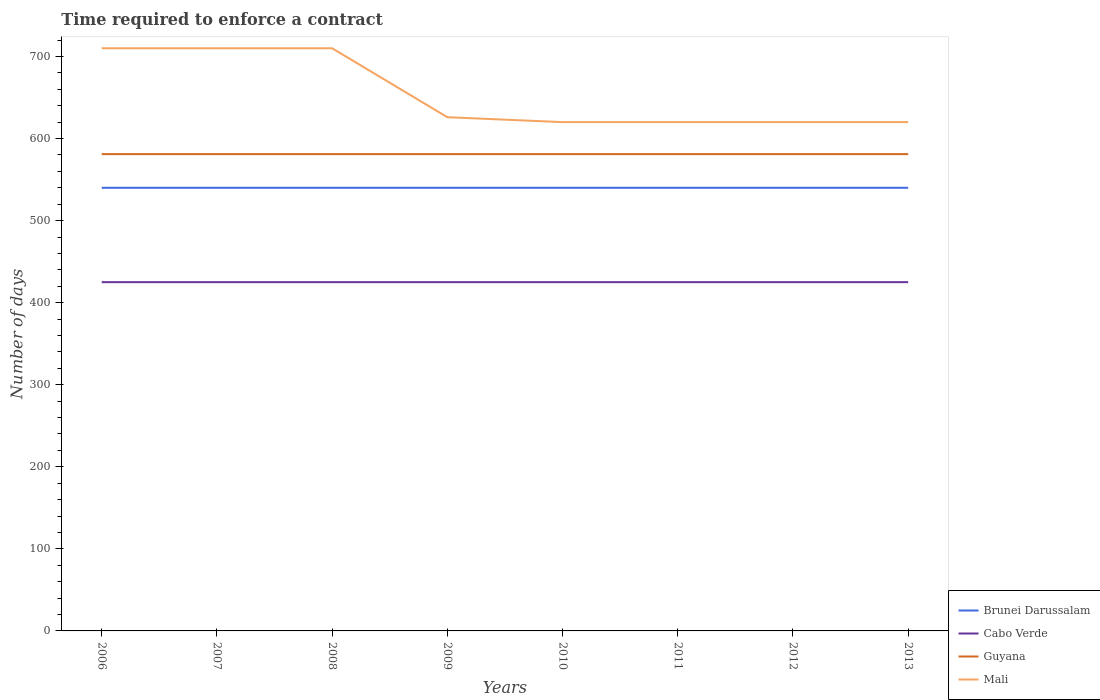Does the line corresponding to Guyana intersect with the line corresponding to Mali?
Provide a short and direct response. No. Is the number of lines equal to the number of legend labels?
Make the answer very short. Yes. Across all years, what is the maximum number of days required to enforce a contract in Brunei Darussalam?
Your answer should be compact. 540. In which year was the number of days required to enforce a contract in Mali maximum?
Provide a short and direct response. 2010. What is the difference between the highest and the second highest number of days required to enforce a contract in Guyana?
Offer a terse response. 0. What is the difference between the highest and the lowest number of days required to enforce a contract in Guyana?
Provide a succinct answer. 0. How many years are there in the graph?
Provide a succinct answer. 8. What is the difference between two consecutive major ticks on the Y-axis?
Your answer should be very brief. 100. Are the values on the major ticks of Y-axis written in scientific E-notation?
Keep it short and to the point. No. Where does the legend appear in the graph?
Offer a terse response. Bottom right. How are the legend labels stacked?
Offer a terse response. Vertical. What is the title of the graph?
Provide a short and direct response. Time required to enforce a contract. Does "South Sudan" appear as one of the legend labels in the graph?
Keep it short and to the point. No. What is the label or title of the Y-axis?
Your response must be concise. Number of days. What is the Number of days of Brunei Darussalam in 2006?
Keep it short and to the point. 540. What is the Number of days of Cabo Verde in 2006?
Provide a short and direct response. 425. What is the Number of days of Guyana in 2006?
Provide a succinct answer. 581. What is the Number of days in Mali in 2006?
Offer a very short reply. 710. What is the Number of days in Brunei Darussalam in 2007?
Offer a terse response. 540. What is the Number of days in Cabo Verde in 2007?
Your answer should be compact. 425. What is the Number of days in Guyana in 2007?
Offer a very short reply. 581. What is the Number of days in Mali in 2007?
Make the answer very short. 710. What is the Number of days in Brunei Darussalam in 2008?
Provide a succinct answer. 540. What is the Number of days in Cabo Verde in 2008?
Offer a very short reply. 425. What is the Number of days in Guyana in 2008?
Make the answer very short. 581. What is the Number of days of Mali in 2008?
Ensure brevity in your answer.  710. What is the Number of days in Brunei Darussalam in 2009?
Keep it short and to the point. 540. What is the Number of days of Cabo Verde in 2009?
Keep it short and to the point. 425. What is the Number of days in Guyana in 2009?
Ensure brevity in your answer.  581. What is the Number of days of Mali in 2009?
Provide a short and direct response. 626. What is the Number of days of Brunei Darussalam in 2010?
Provide a short and direct response. 540. What is the Number of days of Cabo Verde in 2010?
Offer a terse response. 425. What is the Number of days in Guyana in 2010?
Give a very brief answer. 581. What is the Number of days in Mali in 2010?
Your response must be concise. 620. What is the Number of days of Brunei Darussalam in 2011?
Make the answer very short. 540. What is the Number of days in Cabo Verde in 2011?
Your response must be concise. 425. What is the Number of days of Guyana in 2011?
Offer a very short reply. 581. What is the Number of days in Mali in 2011?
Keep it short and to the point. 620. What is the Number of days in Brunei Darussalam in 2012?
Give a very brief answer. 540. What is the Number of days of Cabo Verde in 2012?
Offer a very short reply. 425. What is the Number of days in Guyana in 2012?
Offer a terse response. 581. What is the Number of days of Mali in 2012?
Make the answer very short. 620. What is the Number of days in Brunei Darussalam in 2013?
Offer a very short reply. 540. What is the Number of days of Cabo Verde in 2013?
Offer a terse response. 425. What is the Number of days in Guyana in 2013?
Keep it short and to the point. 581. What is the Number of days in Mali in 2013?
Offer a very short reply. 620. Across all years, what is the maximum Number of days of Brunei Darussalam?
Give a very brief answer. 540. Across all years, what is the maximum Number of days of Cabo Verde?
Your answer should be compact. 425. Across all years, what is the maximum Number of days in Guyana?
Your answer should be very brief. 581. Across all years, what is the maximum Number of days in Mali?
Give a very brief answer. 710. Across all years, what is the minimum Number of days of Brunei Darussalam?
Offer a very short reply. 540. Across all years, what is the minimum Number of days of Cabo Verde?
Provide a short and direct response. 425. Across all years, what is the minimum Number of days in Guyana?
Your response must be concise. 581. Across all years, what is the minimum Number of days of Mali?
Offer a very short reply. 620. What is the total Number of days in Brunei Darussalam in the graph?
Your answer should be very brief. 4320. What is the total Number of days of Cabo Verde in the graph?
Offer a very short reply. 3400. What is the total Number of days of Guyana in the graph?
Provide a short and direct response. 4648. What is the total Number of days of Mali in the graph?
Your response must be concise. 5236. What is the difference between the Number of days in Cabo Verde in 2006 and that in 2007?
Your answer should be compact. 0. What is the difference between the Number of days in Guyana in 2006 and that in 2007?
Your answer should be very brief. 0. What is the difference between the Number of days of Brunei Darussalam in 2006 and that in 2008?
Offer a terse response. 0. What is the difference between the Number of days of Cabo Verde in 2006 and that in 2009?
Offer a terse response. 0. What is the difference between the Number of days in Guyana in 2006 and that in 2009?
Ensure brevity in your answer.  0. What is the difference between the Number of days in Mali in 2006 and that in 2009?
Your answer should be very brief. 84. What is the difference between the Number of days in Guyana in 2006 and that in 2010?
Your response must be concise. 0. What is the difference between the Number of days of Cabo Verde in 2006 and that in 2011?
Keep it short and to the point. 0. What is the difference between the Number of days in Brunei Darussalam in 2006 and that in 2012?
Provide a short and direct response. 0. What is the difference between the Number of days of Mali in 2006 and that in 2012?
Provide a short and direct response. 90. What is the difference between the Number of days in Brunei Darussalam in 2006 and that in 2013?
Ensure brevity in your answer.  0. What is the difference between the Number of days in Cabo Verde in 2006 and that in 2013?
Your response must be concise. 0. What is the difference between the Number of days in Guyana in 2006 and that in 2013?
Keep it short and to the point. 0. What is the difference between the Number of days in Brunei Darussalam in 2007 and that in 2008?
Give a very brief answer. 0. What is the difference between the Number of days of Cabo Verde in 2007 and that in 2008?
Offer a terse response. 0. What is the difference between the Number of days of Guyana in 2007 and that in 2008?
Keep it short and to the point. 0. What is the difference between the Number of days in Mali in 2007 and that in 2008?
Keep it short and to the point. 0. What is the difference between the Number of days of Brunei Darussalam in 2007 and that in 2009?
Keep it short and to the point. 0. What is the difference between the Number of days of Guyana in 2007 and that in 2009?
Your response must be concise. 0. What is the difference between the Number of days of Brunei Darussalam in 2007 and that in 2010?
Offer a very short reply. 0. What is the difference between the Number of days in Cabo Verde in 2007 and that in 2010?
Your answer should be very brief. 0. What is the difference between the Number of days in Mali in 2007 and that in 2010?
Ensure brevity in your answer.  90. What is the difference between the Number of days of Brunei Darussalam in 2007 and that in 2011?
Your response must be concise. 0. What is the difference between the Number of days in Cabo Verde in 2007 and that in 2011?
Your answer should be compact. 0. What is the difference between the Number of days of Guyana in 2007 and that in 2011?
Give a very brief answer. 0. What is the difference between the Number of days of Cabo Verde in 2007 and that in 2012?
Ensure brevity in your answer.  0. What is the difference between the Number of days of Guyana in 2007 and that in 2012?
Keep it short and to the point. 0. What is the difference between the Number of days of Mali in 2007 and that in 2012?
Give a very brief answer. 90. What is the difference between the Number of days of Brunei Darussalam in 2007 and that in 2013?
Ensure brevity in your answer.  0. What is the difference between the Number of days in Guyana in 2007 and that in 2013?
Keep it short and to the point. 0. What is the difference between the Number of days in Brunei Darussalam in 2008 and that in 2009?
Your response must be concise. 0. What is the difference between the Number of days in Guyana in 2008 and that in 2009?
Give a very brief answer. 0. What is the difference between the Number of days in Mali in 2008 and that in 2009?
Your answer should be very brief. 84. What is the difference between the Number of days in Brunei Darussalam in 2008 and that in 2010?
Your answer should be compact. 0. What is the difference between the Number of days in Cabo Verde in 2008 and that in 2010?
Offer a terse response. 0. What is the difference between the Number of days in Mali in 2008 and that in 2010?
Keep it short and to the point. 90. What is the difference between the Number of days in Brunei Darussalam in 2008 and that in 2011?
Your response must be concise. 0. What is the difference between the Number of days in Cabo Verde in 2008 and that in 2011?
Keep it short and to the point. 0. What is the difference between the Number of days in Mali in 2008 and that in 2011?
Ensure brevity in your answer.  90. What is the difference between the Number of days in Mali in 2008 and that in 2012?
Give a very brief answer. 90. What is the difference between the Number of days of Brunei Darussalam in 2008 and that in 2013?
Provide a succinct answer. 0. What is the difference between the Number of days of Cabo Verde in 2008 and that in 2013?
Your answer should be compact. 0. What is the difference between the Number of days in Guyana in 2008 and that in 2013?
Give a very brief answer. 0. What is the difference between the Number of days of Mali in 2008 and that in 2013?
Ensure brevity in your answer.  90. What is the difference between the Number of days of Cabo Verde in 2009 and that in 2010?
Provide a short and direct response. 0. What is the difference between the Number of days of Cabo Verde in 2009 and that in 2011?
Give a very brief answer. 0. What is the difference between the Number of days in Guyana in 2009 and that in 2011?
Offer a very short reply. 0. What is the difference between the Number of days of Mali in 2009 and that in 2011?
Offer a very short reply. 6. What is the difference between the Number of days in Brunei Darussalam in 2009 and that in 2012?
Your answer should be compact. 0. What is the difference between the Number of days of Guyana in 2009 and that in 2012?
Your response must be concise. 0. What is the difference between the Number of days in Mali in 2009 and that in 2012?
Ensure brevity in your answer.  6. What is the difference between the Number of days in Cabo Verde in 2009 and that in 2013?
Provide a succinct answer. 0. What is the difference between the Number of days in Mali in 2009 and that in 2013?
Your answer should be very brief. 6. What is the difference between the Number of days in Brunei Darussalam in 2010 and that in 2011?
Provide a short and direct response. 0. What is the difference between the Number of days of Cabo Verde in 2010 and that in 2012?
Offer a terse response. 0. What is the difference between the Number of days in Guyana in 2010 and that in 2012?
Your answer should be very brief. 0. What is the difference between the Number of days of Brunei Darussalam in 2010 and that in 2013?
Keep it short and to the point. 0. What is the difference between the Number of days in Cabo Verde in 2010 and that in 2013?
Keep it short and to the point. 0. What is the difference between the Number of days of Guyana in 2011 and that in 2012?
Keep it short and to the point. 0. What is the difference between the Number of days in Brunei Darussalam in 2011 and that in 2013?
Provide a succinct answer. 0. What is the difference between the Number of days in Cabo Verde in 2011 and that in 2013?
Keep it short and to the point. 0. What is the difference between the Number of days of Guyana in 2011 and that in 2013?
Offer a terse response. 0. What is the difference between the Number of days of Guyana in 2012 and that in 2013?
Your response must be concise. 0. What is the difference between the Number of days in Brunei Darussalam in 2006 and the Number of days in Cabo Verde in 2007?
Your answer should be very brief. 115. What is the difference between the Number of days of Brunei Darussalam in 2006 and the Number of days of Guyana in 2007?
Make the answer very short. -41. What is the difference between the Number of days in Brunei Darussalam in 2006 and the Number of days in Mali in 2007?
Offer a terse response. -170. What is the difference between the Number of days in Cabo Verde in 2006 and the Number of days in Guyana in 2007?
Ensure brevity in your answer.  -156. What is the difference between the Number of days of Cabo Verde in 2006 and the Number of days of Mali in 2007?
Offer a very short reply. -285. What is the difference between the Number of days in Guyana in 2006 and the Number of days in Mali in 2007?
Your answer should be very brief. -129. What is the difference between the Number of days of Brunei Darussalam in 2006 and the Number of days of Cabo Verde in 2008?
Offer a very short reply. 115. What is the difference between the Number of days in Brunei Darussalam in 2006 and the Number of days in Guyana in 2008?
Your answer should be compact. -41. What is the difference between the Number of days in Brunei Darussalam in 2006 and the Number of days in Mali in 2008?
Your answer should be compact. -170. What is the difference between the Number of days in Cabo Verde in 2006 and the Number of days in Guyana in 2008?
Provide a short and direct response. -156. What is the difference between the Number of days of Cabo Verde in 2006 and the Number of days of Mali in 2008?
Keep it short and to the point. -285. What is the difference between the Number of days in Guyana in 2006 and the Number of days in Mali in 2008?
Offer a terse response. -129. What is the difference between the Number of days in Brunei Darussalam in 2006 and the Number of days in Cabo Verde in 2009?
Your answer should be compact. 115. What is the difference between the Number of days of Brunei Darussalam in 2006 and the Number of days of Guyana in 2009?
Provide a succinct answer. -41. What is the difference between the Number of days of Brunei Darussalam in 2006 and the Number of days of Mali in 2009?
Your response must be concise. -86. What is the difference between the Number of days of Cabo Verde in 2006 and the Number of days of Guyana in 2009?
Your answer should be very brief. -156. What is the difference between the Number of days in Cabo Verde in 2006 and the Number of days in Mali in 2009?
Keep it short and to the point. -201. What is the difference between the Number of days in Guyana in 2006 and the Number of days in Mali in 2009?
Ensure brevity in your answer.  -45. What is the difference between the Number of days of Brunei Darussalam in 2006 and the Number of days of Cabo Verde in 2010?
Give a very brief answer. 115. What is the difference between the Number of days of Brunei Darussalam in 2006 and the Number of days of Guyana in 2010?
Give a very brief answer. -41. What is the difference between the Number of days of Brunei Darussalam in 2006 and the Number of days of Mali in 2010?
Your answer should be very brief. -80. What is the difference between the Number of days of Cabo Verde in 2006 and the Number of days of Guyana in 2010?
Provide a succinct answer. -156. What is the difference between the Number of days in Cabo Verde in 2006 and the Number of days in Mali in 2010?
Provide a succinct answer. -195. What is the difference between the Number of days in Guyana in 2006 and the Number of days in Mali in 2010?
Your answer should be compact. -39. What is the difference between the Number of days of Brunei Darussalam in 2006 and the Number of days of Cabo Verde in 2011?
Provide a short and direct response. 115. What is the difference between the Number of days of Brunei Darussalam in 2006 and the Number of days of Guyana in 2011?
Ensure brevity in your answer.  -41. What is the difference between the Number of days in Brunei Darussalam in 2006 and the Number of days in Mali in 2011?
Provide a succinct answer. -80. What is the difference between the Number of days in Cabo Verde in 2006 and the Number of days in Guyana in 2011?
Your answer should be compact. -156. What is the difference between the Number of days of Cabo Verde in 2006 and the Number of days of Mali in 2011?
Keep it short and to the point. -195. What is the difference between the Number of days in Guyana in 2006 and the Number of days in Mali in 2011?
Keep it short and to the point. -39. What is the difference between the Number of days of Brunei Darussalam in 2006 and the Number of days of Cabo Verde in 2012?
Provide a succinct answer. 115. What is the difference between the Number of days in Brunei Darussalam in 2006 and the Number of days in Guyana in 2012?
Give a very brief answer. -41. What is the difference between the Number of days of Brunei Darussalam in 2006 and the Number of days of Mali in 2012?
Provide a succinct answer. -80. What is the difference between the Number of days of Cabo Verde in 2006 and the Number of days of Guyana in 2012?
Your response must be concise. -156. What is the difference between the Number of days in Cabo Verde in 2006 and the Number of days in Mali in 2012?
Provide a short and direct response. -195. What is the difference between the Number of days of Guyana in 2006 and the Number of days of Mali in 2012?
Give a very brief answer. -39. What is the difference between the Number of days in Brunei Darussalam in 2006 and the Number of days in Cabo Verde in 2013?
Provide a succinct answer. 115. What is the difference between the Number of days of Brunei Darussalam in 2006 and the Number of days of Guyana in 2013?
Keep it short and to the point. -41. What is the difference between the Number of days of Brunei Darussalam in 2006 and the Number of days of Mali in 2013?
Provide a short and direct response. -80. What is the difference between the Number of days in Cabo Verde in 2006 and the Number of days in Guyana in 2013?
Your answer should be compact. -156. What is the difference between the Number of days in Cabo Verde in 2006 and the Number of days in Mali in 2013?
Your answer should be very brief. -195. What is the difference between the Number of days of Guyana in 2006 and the Number of days of Mali in 2013?
Offer a terse response. -39. What is the difference between the Number of days of Brunei Darussalam in 2007 and the Number of days of Cabo Verde in 2008?
Your response must be concise. 115. What is the difference between the Number of days in Brunei Darussalam in 2007 and the Number of days in Guyana in 2008?
Give a very brief answer. -41. What is the difference between the Number of days of Brunei Darussalam in 2007 and the Number of days of Mali in 2008?
Your answer should be compact. -170. What is the difference between the Number of days of Cabo Verde in 2007 and the Number of days of Guyana in 2008?
Your answer should be very brief. -156. What is the difference between the Number of days in Cabo Verde in 2007 and the Number of days in Mali in 2008?
Make the answer very short. -285. What is the difference between the Number of days of Guyana in 2007 and the Number of days of Mali in 2008?
Make the answer very short. -129. What is the difference between the Number of days in Brunei Darussalam in 2007 and the Number of days in Cabo Verde in 2009?
Make the answer very short. 115. What is the difference between the Number of days of Brunei Darussalam in 2007 and the Number of days of Guyana in 2009?
Offer a terse response. -41. What is the difference between the Number of days of Brunei Darussalam in 2007 and the Number of days of Mali in 2009?
Offer a terse response. -86. What is the difference between the Number of days in Cabo Verde in 2007 and the Number of days in Guyana in 2009?
Give a very brief answer. -156. What is the difference between the Number of days in Cabo Verde in 2007 and the Number of days in Mali in 2009?
Give a very brief answer. -201. What is the difference between the Number of days in Guyana in 2007 and the Number of days in Mali in 2009?
Offer a terse response. -45. What is the difference between the Number of days in Brunei Darussalam in 2007 and the Number of days in Cabo Verde in 2010?
Give a very brief answer. 115. What is the difference between the Number of days in Brunei Darussalam in 2007 and the Number of days in Guyana in 2010?
Keep it short and to the point. -41. What is the difference between the Number of days of Brunei Darussalam in 2007 and the Number of days of Mali in 2010?
Your answer should be compact. -80. What is the difference between the Number of days of Cabo Verde in 2007 and the Number of days of Guyana in 2010?
Provide a short and direct response. -156. What is the difference between the Number of days of Cabo Verde in 2007 and the Number of days of Mali in 2010?
Ensure brevity in your answer.  -195. What is the difference between the Number of days in Guyana in 2007 and the Number of days in Mali in 2010?
Your answer should be very brief. -39. What is the difference between the Number of days of Brunei Darussalam in 2007 and the Number of days of Cabo Verde in 2011?
Keep it short and to the point. 115. What is the difference between the Number of days of Brunei Darussalam in 2007 and the Number of days of Guyana in 2011?
Keep it short and to the point. -41. What is the difference between the Number of days in Brunei Darussalam in 2007 and the Number of days in Mali in 2011?
Give a very brief answer. -80. What is the difference between the Number of days in Cabo Verde in 2007 and the Number of days in Guyana in 2011?
Ensure brevity in your answer.  -156. What is the difference between the Number of days of Cabo Verde in 2007 and the Number of days of Mali in 2011?
Ensure brevity in your answer.  -195. What is the difference between the Number of days of Guyana in 2007 and the Number of days of Mali in 2011?
Keep it short and to the point. -39. What is the difference between the Number of days of Brunei Darussalam in 2007 and the Number of days of Cabo Verde in 2012?
Your response must be concise. 115. What is the difference between the Number of days in Brunei Darussalam in 2007 and the Number of days in Guyana in 2012?
Your answer should be compact. -41. What is the difference between the Number of days of Brunei Darussalam in 2007 and the Number of days of Mali in 2012?
Provide a succinct answer. -80. What is the difference between the Number of days of Cabo Verde in 2007 and the Number of days of Guyana in 2012?
Keep it short and to the point. -156. What is the difference between the Number of days of Cabo Verde in 2007 and the Number of days of Mali in 2012?
Your answer should be compact. -195. What is the difference between the Number of days of Guyana in 2007 and the Number of days of Mali in 2012?
Ensure brevity in your answer.  -39. What is the difference between the Number of days in Brunei Darussalam in 2007 and the Number of days in Cabo Verde in 2013?
Offer a terse response. 115. What is the difference between the Number of days of Brunei Darussalam in 2007 and the Number of days of Guyana in 2013?
Your response must be concise. -41. What is the difference between the Number of days of Brunei Darussalam in 2007 and the Number of days of Mali in 2013?
Make the answer very short. -80. What is the difference between the Number of days in Cabo Verde in 2007 and the Number of days in Guyana in 2013?
Offer a very short reply. -156. What is the difference between the Number of days in Cabo Verde in 2007 and the Number of days in Mali in 2013?
Make the answer very short. -195. What is the difference between the Number of days of Guyana in 2007 and the Number of days of Mali in 2013?
Keep it short and to the point. -39. What is the difference between the Number of days in Brunei Darussalam in 2008 and the Number of days in Cabo Verde in 2009?
Offer a very short reply. 115. What is the difference between the Number of days of Brunei Darussalam in 2008 and the Number of days of Guyana in 2009?
Provide a short and direct response. -41. What is the difference between the Number of days in Brunei Darussalam in 2008 and the Number of days in Mali in 2009?
Provide a succinct answer. -86. What is the difference between the Number of days of Cabo Verde in 2008 and the Number of days of Guyana in 2009?
Provide a succinct answer. -156. What is the difference between the Number of days of Cabo Verde in 2008 and the Number of days of Mali in 2009?
Ensure brevity in your answer.  -201. What is the difference between the Number of days in Guyana in 2008 and the Number of days in Mali in 2009?
Make the answer very short. -45. What is the difference between the Number of days in Brunei Darussalam in 2008 and the Number of days in Cabo Verde in 2010?
Provide a succinct answer. 115. What is the difference between the Number of days of Brunei Darussalam in 2008 and the Number of days of Guyana in 2010?
Your answer should be compact. -41. What is the difference between the Number of days in Brunei Darussalam in 2008 and the Number of days in Mali in 2010?
Offer a very short reply. -80. What is the difference between the Number of days in Cabo Verde in 2008 and the Number of days in Guyana in 2010?
Offer a very short reply. -156. What is the difference between the Number of days in Cabo Verde in 2008 and the Number of days in Mali in 2010?
Your answer should be compact. -195. What is the difference between the Number of days of Guyana in 2008 and the Number of days of Mali in 2010?
Provide a short and direct response. -39. What is the difference between the Number of days of Brunei Darussalam in 2008 and the Number of days of Cabo Verde in 2011?
Ensure brevity in your answer.  115. What is the difference between the Number of days of Brunei Darussalam in 2008 and the Number of days of Guyana in 2011?
Offer a very short reply. -41. What is the difference between the Number of days in Brunei Darussalam in 2008 and the Number of days in Mali in 2011?
Give a very brief answer. -80. What is the difference between the Number of days of Cabo Verde in 2008 and the Number of days of Guyana in 2011?
Your answer should be compact. -156. What is the difference between the Number of days of Cabo Verde in 2008 and the Number of days of Mali in 2011?
Provide a short and direct response. -195. What is the difference between the Number of days of Guyana in 2008 and the Number of days of Mali in 2011?
Provide a succinct answer. -39. What is the difference between the Number of days of Brunei Darussalam in 2008 and the Number of days of Cabo Verde in 2012?
Your response must be concise. 115. What is the difference between the Number of days of Brunei Darussalam in 2008 and the Number of days of Guyana in 2012?
Provide a succinct answer. -41. What is the difference between the Number of days of Brunei Darussalam in 2008 and the Number of days of Mali in 2012?
Ensure brevity in your answer.  -80. What is the difference between the Number of days in Cabo Verde in 2008 and the Number of days in Guyana in 2012?
Offer a very short reply. -156. What is the difference between the Number of days in Cabo Verde in 2008 and the Number of days in Mali in 2012?
Offer a very short reply. -195. What is the difference between the Number of days in Guyana in 2008 and the Number of days in Mali in 2012?
Your answer should be compact. -39. What is the difference between the Number of days of Brunei Darussalam in 2008 and the Number of days of Cabo Verde in 2013?
Keep it short and to the point. 115. What is the difference between the Number of days of Brunei Darussalam in 2008 and the Number of days of Guyana in 2013?
Provide a short and direct response. -41. What is the difference between the Number of days in Brunei Darussalam in 2008 and the Number of days in Mali in 2013?
Give a very brief answer. -80. What is the difference between the Number of days of Cabo Verde in 2008 and the Number of days of Guyana in 2013?
Give a very brief answer. -156. What is the difference between the Number of days of Cabo Verde in 2008 and the Number of days of Mali in 2013?
Provide a succinct answer. -195. What is the difference between the Number of days in Guyana in 2008 and the Number of days in Mali in 2013?
Offer a terse response. -39. What is the difference between the Number of days of Brunei Darussalam in 2009 and the Number of days of Cabo Verde in 2010?
Your answer should be very brief. 115. What is the difference between the Number of days in Brunei Darussalam in 2009 and the Number of days in Guyana in 2010?
Your response must be concise. -41. What is the difference between the Number of days of Brunei Darussalam in 2009 and the Number of days of Mali in 2010?
Ensure brevity in your answer.  -80. What is the difference between the Number of days of Cabo Verde in 2009 and the Number of days of Guyana in 2010?
Your response must be concise. -156. What is the difference between the Number of days in Cabo Verde in 2009 and the Number of days in Mali in 2010?
Give a very brief answer. -195. What is the difference between the Number of days in Guyana in 2009 and the Number of days in Mali in 2010?
Provide a succinct answer. -39. What is the difference between the Number of days of Brunei Darussalam in 2009 and the Number of days of Cabo Verde in 2011?
Give a very brief answer. 115. What is the difference between the Number of days in Brunei Darussalam in 2009 and the Number of days in Guyana in 2011?
Keep it short and to the point. -41. What is the difference between the Number of days in Brunei Darussalam in 2009 and the Number of days in Mali in 2011?
Offer a very short reply. -80. What is the difference between the Number of days of Cabo Verde in 2009 and the Number of days of Guyana in 2011?
Keep it short and to the point. -156. What is the difference between the Number of days in Cabo Verde in 2009 and the Number of days in Mali in 2011?
Provide a succinct answer. -195. What is the difference between the Number of days in Guyana in 2009 and the Number of days in Mali in 2011?
Provide a short and direct response. -39. What is the difference between the Number of days in Brunei Darussalam in 2009 and the Number of days in Cabo Verde in 2012?
Provide a short and direct response. 115. What is the difference between the Number of days of Brunei Darussalam in 2009 and the Number of days of Guyana in 2012?
Your response must be concise. -41. What is the difference between the Number of days of Brunei Darussalam in 2009 and the Number of days of Mali in 2012?
Offer a very short reply. -80. What is the difference between the Number of days in Cabo Verde in 2009 and the Number of days in Guyana in 2012?
Your answer should be compact. -156. What is the difference between the Number of days of Cabo Verde in 2009 and the Number of days of Mali in 2012?
Ensure brevity in your answer.  -195. What is the difference between the Number of days of Guyana in 2009 and the Number of days of Mali in 2012?
Your answer should be very brief. -39. What is the difference between the Number of days in Brunei Darussalam in 2009 and the Number of days in Cabo Verde in 2013?
Give a very brief answer. 115. What is the difference between the Number of days in Brunei Darussalam in 2009 and the Number of days in Guyana in 2013?
Keep it short and to the point. -41. What is the difference between the Number of days in Brunei Darussalam in 2009 and the Number of days in Mali in 2013?
Offer a terse response. -80. What is the difference between the Number of days in Cabo Verde in 2009 and the Number of days in Guyana in 2013?
Your answer should be compact. -156. What is the difference between the Number of days of Cabo Verde in 2009 and the Number of days of Mali in 2013?
Make the answer very short. -195. What is the difference between the Number of days in Guyana in 2009 and the Number of days in Mali in 2013?
Provide a succinct answer. -39. What is the difference between the Number of days in Brunei Darussalam in 2010 and the Number of days in Cabo Verde in 2011?
Offer a terse response. 115. What is the difference between the Number of days of Brunei Darussalam in 2010 and the Number of days of Guyana in 2011?
Ensure brevity in your answer.  -41. What is the difference between the Number of days of Brunei Darussalam in 2010 and the Number of days of Mali in 2011?
Offer a very short reply. -80. What is the difference between the Number of days of Cabo Verde in 2010 and the Number of days of Guyana in 2011?
Make the answer very short. -156. What is the difference between the Number of days in Cabo Verde in 2010 and the Number of days in Mali in 2011?
Your answer should be very brief. -195. What is the difference between the Number of days of Guyana in 2010 and the Number of days of Mali in 2011?
Provide a short and direct response. -39. What is the difference between the Number of days in Brunei Darussalam in 2010 and the Number of days in Cabo Verde in 2012?
Your answer should be very brief. 115. What is the difference between the Number of days of Brunei Darussalam in 2010 and the Number of days of Guyana in 2012?
Make the answer very short. -41. What is the difference between the Number of days of Brunei Darussalam in 2010 and the Number of days of Mali in 2012?
Ensure brevity in your answer.  -80. What is the difference between the Number of days in Cabo Verde in 2010 and the Number of days in Guyana in 2012?
Ensure brevity in your answer.  -156. What is the difference between the Number of days of Cabo Verde in 2010 and the Number of days of Mali in 2012?
Offer a terse response. -195. What is the difference between the Number of days of Guyana in 2010 and the Number of days of Mali in 2012?
Give a very brief answer. -39. What is the difference between the Number of days in Brunei Darussalam in 2010 and the Number of days in Cabo Verde in 2013?
Your answer should be compact. 115. What is the difference between the Number of days in Brunei Darussalam in 2010 and the Number of days in Guyana in 2013?
Keep it short and to the point. -41. What is the difference between the Number of days in Brunei Darussalam in 2010 and the Number of days in Mali in 2013?
Keep it short and to the point. -80. What is the difference between the Number of days in Cabo Verde in 2010 and the Number of days in Guyana in 2013?
Your answer should be very brief. -156. What is the difference between the Number of days of Cabo Verde in 2010 and the Number of days of Mali in 2013?
Your answer should be very brief. -195. What is the difference between the Number of days in Guyana in 2010 and the Number of days in Mali in 2013?
Provide a succinct answer. -39. What is the difference between the Number of days of Brunei Darussalam in 2011 and the Number of days of Cabo Verde in 2012?
Offer a terse response. 115. What is the difference between the Number of days of Brunei Darussalam in 2011 and the Number of days of Guyana in 2012?
Ensure brevity in your answer.  -41. What is the difference between the Number of days of Brunei Darussalam in 2011 and the Number of days of Mali in 2012?
Your answer should be very brief. -80. What is the difference between the Number of days of Cabo Verde in 2011 and the Number of days of Guyana in 2012?
Keep it short and to the point. -156. What is the difference between the Number of days of Cabo Verde in 2011 and the Number of days of Mali in 2012?
Offer a terse response. -195. What is the difference between the Number of days in Guyana in 2011 and the Number of days in Mali in 2012?
Your response must be concise. -39. What is the difference between the Number of days in Brunei Darussalam in 2011 and the Number of days in Cabo Verde in 2013?
Ensure brevity in your answer.  115. What is the difference between the Number of days in Brunei Darussalam in 2011 and the Number of days in Guyana in 2013?
Offer a very short reply. -41. What is the difference between the Number of days in Brunei Darussalam in 2011 and the Number of days in Mali in 2013?
Provide a short and direct response. -80. What is the difference between the Number of days of Cabo Verde in 2011 and the Number of days of Guyana in 2013?
Your answer should be very brief. -156. What is the difference between the Number of days of Cabo Verde in 2011 and the Number of days of Mali in 2013?
Keep it short and to the point. -195. What is the difference between the Number of days in Guyana in 2011 and the Number of days in Mali in 2013?
Provide a succinct answer. -39. What is the difference between the Number of days of Brunei Darussalam in 2012 and the Number of days of Cabo Verde in 2013?
Keep it short and to the point. 115. What is the difference between the Number of days in Brunei Darussalam in 2012 and the Number of days in Guyana in 2013?
Ensure brevity in your answer.  -41. What is the difference between the Number of days in Brunei Darussalam in 2012 and the Number of days in Mali in 2013?
Ensure brevity in your answer.  -80. What is the difference between the Number of days in Cabo Verde in 2012 and the Number of days in Guyana in 2013?
Provide a short and direct response. -156. What is the difference between the Number of days of Cabo Verde in 2012 and the Number of days of Mali in 2013?
Make the answer very short. -195. What is the difference between the Number of days in Guyana in 2012 and the Number of days in Mali in 2013?
Your response must be concise. -39. What is the average Number of days in Brunei Darussalam per year?
Your response must be concise. 540. What is the average Number of days in Cabo Verde per year?
Provide a short and direct response. 425. What is the average Number of days in Guyana per year?
Provide a succinct answer. 581. What is the average Number of days in Mali per year?
Your response must be concise. 654.5. In the year 2006, what is the difference between the Number of days in Brunei Darussalam and Number of days in Cabo Verde?
Offer a very short reply. 115. In the year 2006, what is the difference between the Number of days in Brunei Darussalam and Number of days in Guyana?
Ensure brevity in your answer.  -41. In the year 2006, what is the difference between the Number of days of Brunei Darussalam and Number of days of Mali?
Ensure brevity in your answer.  -170. In the year 2006, what is the difference between the Number of days of Cabo Verde and Number of days of Guyana?
Your answer should be very brief. -156. In the year 2006, what is the difference between the Number of days in Cabo Verde and Number of days in Mali?
Offer a very short reply. -285. In the year 2006, what is the difference between the Number of days of Guyana and Number of days of Mali?
Your response must be concise. -129. In the year 2007, what is the difference between the Number of days of Brunei Darussalam and Number of days of Cabo Verde?
Make the answer very short. 115. In the year 2007, what is the difference between the Number of days in Brunei Darussalam and Number of days in Guyana?
Offer a very short reply. -41. In the year 2007, what is the difference between the Number of days in Brunei Darussalam and Number of days in Mali?
Your answer should be very brief. -170. In the year 2007, what is the difference between the Number of days in Cabo Verde and Number of days in Guyana?
Offer a terse response. -156. In the year 2007, what is the difference between the Number of days in Cabo Verde and Number of days in Mali?
Your answer should be compact. -285. In the year 2007, what is the difference between the Number of days in Guyana and Number of days in Mali?
Ensure brevity in your answer.  -129. In the year 2008, what is the difference between the Number of days in Brunei Darussalam and Number of days in Cabo Verde?
Make the answer very short. 115. In the year 2008, what is the difference between the Number of days of Brunei Darussalam and Number of days of Guyana?
Your answer should be very brief. -41. In the year 2008, what is the difference between the Number of days of Brunei Darussalam and Number of days of Mali?
Offer a terse response. -170. In the year 2008, what is the difference between the Number of days in Cabo Verde and Number of days in Guyana?
Your answer should be compact. -156. In the year 2008, what is the difference between the Number of days in Cabo Verde and Number of days in Mali?
Provide a short and direct response. -285. In the year 2008, what is the difference between the Number of days in Guyana and Number of days in Mali?
Make the answer very short. -129. In the year 2009, what is the difference between the Number of days in Brunei Darussalam and Number of days in Cabo Verde?
Provide a succinct answer. 115. In the year 2009, what is the difference between the Number of days of Brunei Darussalam and Number of days of Guyana?
Offer a terse response. -41. In the year 2009, what is the difference between the Number of days in Brunei Darussalam and Number of days in Mali?
Give a very brief answer. -86. In the year 2009, what is the difference between the Number of days of Cabo Verde and Number of days of Guyana?
Offer a terse response. -156. In the year 2009, what is the difference between the Number of days of Cabo Verde and Number of days of Mali?
Keep it short and to the point. -201. In the year 2009, what is the difference between the Number of days of Guyana and Number of days of Mali?
Your answer should be very brief. -45. In the year 2010, what is the difference between the Number of days in Brunei Darussalam and Number of days in Cabo Verde?
Ensure brevity in your answer.  115. In the year 2010, what is the difference between the Number of days of Brunei Darussalam and Number of days of Guyana?
Ensure brevity in your answer.  -41. In the year 2010, what is the difference between the Number of days of Brunei Darussalam and Number of days of Mali?
Make the answer very short. -80. In the year 2010, what is the difference between the Number of days in Cabo Verde and Number of days in Guyana?
Keep it short and to the point. -156. In the year 2010, what is the difference between the Number of days of Cabo Verde and Number of days of Mali?
Give a very brief answer. -195. In the year 2010, what is the difference between the Number of days in Guyana and Number of days in Mali?
Ensure brevity in your answer.  -39. In the year 2011, what is the difference between the Number of days in Brunei Darussalam and Number of days in Cabo Verde?
Your answer should be compact. 115. In the year 2011, what is the difference between the Number of days in Brunei Darussalam and Number of days in Guyana?
Offer a terse response. -41. In the year 2011, what is the difference between the Number of days in Brunei Darussalam and Number of days in Mali?
Offer a very short reply. -80. In the year 2011, what is the difference between the Number of days of Cabo Verde and Number of days of Guyana?
Give a very brief answer. -156. In the year 2011, what is the difference between the Number of days in Cabo Verde and Number of days in Mali?
Give a very brief answer. -195. In the year 2011, what is the difference between the Number of days in Guyana and Number of days in Mali?
Provide a succinct answer. -39. In the year 2012, what is the difference between the Number of days in Brunei Darussalam and Number of days in Cabo Verde?
Make the answer very short. 115. In the year 2012, what is the difference between the Number of days in Brunei Darussalam and Number of days in Guyana?
Give a very brief answer. -41. In the year 2012, what is the difference between the Number of days in Brunei Darussalam and Number of days in Mali?
Ensure brevity in your answer.  -80. In the year 2012, what is the difference between the Number of days of Cabo Verde and Number of days of Guyana?
Give a very brief answer. -156. In the year 2012, what is the difference between the Number of days of Cabo Verde and Number of days of Mali?
Give a very brief answer. -195. In the year 2012, what is the difference between the Number of days of Guyana and Number of days of Mali?
Ensure brevity in your answer.  -39. In the year 2013, what is the difference between the Number of days in Brunei Darussalam and Number of days in Cabo Verde?
Offer a terse response. 115. In the year 2013, what is the difference between the Number of days of Brunei Darussalam and Number of days of Guyana?
Ensure brevity in your answer.  -41. In the year 2013, what is the difference between the Number of days of Brunei Darussalam and Number of days of Mali?
Offer a very short reply. -80. In the year 2013, what is the difference between the Number of days in Cabo Verde and Number of days in Guyana?
Provide a short and direct response. -156. In the year 2013, what is the difference between the Number of days of Cabo Verde and Number of days of Mali?
Keep it short and to the point. -195. In the year 2013, what is the difference between the Number of days in Guyana and Number of days in Mali?
Make the answer very short. -39. What is the ratio of the Number of days in Brunei Darussalam in 2006 to that in 2008?
Your answer should be compact. 1. What is the ratio of the Number of days in Mali in 2006 to that in 2008?
Ensure brevity in your answer.  1. What is the ratio of the Number of days of Brunei Darussalam in 2006 to that in 2009?
Your response must be concise. 1. What is the ratio of the Number of days in Cabo Verde in 2006 to that in 2009?
Make the answer very short. 1. What is the ratio of the Number of days in Guyana in 2006 to that in 2009?
Make the answer very short. 1. What is the ratio of the Number of days in Mali in 2006 to that in 2009?
Provide a short and direct response. 1.13. What is the ratio of the Number of days of Mali in 2006 to that in 2010?
Your answer should be very brief. 1.15. What is the ratio of the Number of days of Brunei Darussalam in 2006 to that in 2011?
Give a very brief answer. 1. What is the ratio of the Number of days in Guyana in 2006 to that in 2011?
Your response must be concise. 1. What is the ratio of the Number of days of Mali in 2006 to that in 2011?
Your answer should be very brief. 1.15. What is the ratio of the Number of days of Guyana in 2006 to that in 2012?
Keep it short and to the point. 1. What is the ratio of the Number of days of Mali in 2006 to that in 2012?
Make the answer very short. 1.15. What is the ratio of the Number of days of Cabo Verde in 2006 to that in 2013?
Keep it short and to the point. 1. What is the ratio of the Number of days of Guyana in 2006 to that in 2013?
Your answer should be very brief. 1. What is the ratio of the Number of days of Mali in 2006 to that in 2013?
Your response must be concise. 1.15. What is the ratio of the Number of days in Guyana in 2007 to that in 2008?
Offer a terse response. 1. What is the ratio of the Number of days in Mali in 2007 to that in 2008?
Keep it short and to the point. 1. What is the ratio of the Number of days in Brunei Darussalam in 2007 to that in 2009?
Provide a succinct answer. 1. What is the ratio of the Number of days of Guyana in 2007 to that in 2009?
Keep it short and to the point. 1. What is the ratio of the Number of days in Mali in 2007 to that in 2009?
Keep it short and to the point. 1.13. What is the ratio of the Number of days in Brunei Darussalam in 2007 to that in 2010?
Your response must be concise. 1. What is the ratio of the Number of days in Cabo Verde in 2007 to that in 2010?
Your answer should be compact. 1. What is the ratio of the Number of days in Guyana in 2007 to that in 2010?
Give a very brief answer. 1. What is the ratio of the Number of days in Mali in 2007 to that in 2010?
Your response must be concise. 1.15. What is the ratio of the Number of days in Guyana in 2007 to that in 2011?
Ensure brevity in your answer.  1. What is the ratio of the Number of days in Mali in 2007 to that in 2011?
Your answer should be compact. 1.15. What is the ratio of the Number of days of Cabo Verde in 2007 to that in 2012?
Your answer should be very brief. 1. What is the ratio of the Number of days in Mali in 2007 to that in 2012?
Make the answer very short. 1.15. What is the ratio of the Number of days of Mali in 2007 to that in 2013?
Your answer should be compact. 1.15. What is the ratio of the Number of days in Guyana in 2008 to that in 2009?
Provide a short and direct response. 1. What is the ratio of the Number of days of Mali in 2008 to that in 2009?
Your answer should be very brief. 1.13. What is the ratio of the Number of days of Brunei Darussalam in 2008 to that in 2010?
Give a very brief answer. 1. What is the ratio of the Number of days in Guyana in 2008 to that in 2010?
Give a very brief answer. 1. What is the ratio of the Number of days in Mali in 2008 to that in 2010?
Your answer should be very brief. 1.15. What is the ratio of the Number of days in Brunei Darussalam in 2008 to that in 2011?
Give a very brief answer. 1. What is the ratio of the Number of days in Guyana in 2008 to that in 2011?
Provide a short and direct response. 1. What is the ratio of the Number of days in Mali in 2008 to that in 2011?
Give a very brief answer. 1.15. What is the ratio of the Number of days in Cabo Verde in 2008 to that in 2012?
Keep it short and to the point. 1. What is the ratio of the Number of days of Guyana in 2008 to that in 2012?
Offer a terse response. 1. What is the ratio of the Number of days in Mali in 2008 to that in 2012?
Your response must be concise. 1.15. What is the ratio of the Number of days in Brunei Darussalam in 2008 to that in 2013?
Provide a succinct answer. 1. What is the ratio of the Number of days of Guyana in 2008 to that in 2013?
Keep it short and to the point. 1. What is the ratio of the Number of days of Mali in 2008 to that in 2013?
Provide a succinct answer. 1.15. What is the ratio of the Number of days in Brunei Darussalam in 2009 to that in 2010?
Keep it short and to the point. 1. What is the ratio of the Number of days in Mali in 2009 to that in 2010?
Offer a very short reply. 1.01. What is the ratio of the Number of days of Brunei Darussalam in 2009 to that in 2011?
Keep it short and to the point. 1. What is the ratio of the Number of days of Cabo Verde in 2009 to that in 2011?
Provide a short and direct response. 1. What is the ratio of the Number of days in Mali in 2009 to that in 2011?
Your answer should be very brief. 1.01. What is the ratio of the Number of days in Brunei Darussalam in 2009 to that in 2012?
Make the answer very short. 1. What is the ratio of the Number of days of Guyana in 2009 to that in 2012?
Provide a succinct answer. 1. What is the ratio of the Number of days of Mali in 2009 to that in 2012?
Ensure brevity in your answer.  1.01. What is the ratio of the Number of days in Cabo Verde in 2009 to that in 2013?
Keep it short and to the point. 1. What is the ratio of the Number of days in Mali in 2009 to that in 2013?
Make the answer very short. 1.01. What is the ratio of the Number of days of Brunei Darussalam in 2010 to that in 2011?
Your answer should be compact. 1. What is the ratio of the Number of days of Mali in 2010 to that in 2011?
Ensure brevity in your answer.  1. What is the ratio of the Number of days of Guyana in 2010 to that in 2012?
Offer a terse response. 1. What is the ratio of the Number of days of Brunei Darussalam in 2010 to that in 2013?
Your response must be concise. 1. What is the ratio of the Number of days in Mali in 2010 to that in 2013?
Your answer should be compact. 1. What is the ratio of the Number of days in Cabo Verde in 2011 to that in 2012?
Ensure brevity in your answer.  1. What is the ratio of the Number of days of Mali in 2011 to that in 2012?
Your answer should be compact. 1. What is the ratio of the Number of days in Brunei Darussalam in 2011 to that in 2013?
Ensure brevity in your answer.  1. What is the ratio of the Number of days of Cabo Verde in 2011 to that in 2013?
Provide a succinct answer. 1. What is the ratio of the Number of days of Guyana in 2011 to that in 2013?
Offer a terse response. 1. What is the ratio of the Number of days in Brunei Darussalam in 2012 to that in 2013?
Ensure brevity in your answer.  1. What is the ratio of the Number of days of Guyana in 2012 to that in 2013?
Provide a short and direct response. 1. What is the ratio of the Number of days of Mali in 2012 to that in 2013?
Your response must be concise. 1. What is the difference between the highest and the second highest Number of days of Brunei Darussalam?
Offer a terse response. 0. What is the difference between the highest and the second highest Number of days of Guyana?
Provide a short and direct response. 0. What is the difference between the highest and the lowest Number of days in Brunei Darussalam?
Keep it short and to the point. 0. What is the difference between the highest and the lowest Number of days in Cabo Verde?
Offer a terse response. 0. What is the difference between the highest and the lowest Number of days in Mali?
Your answer should be very brief. 90. 